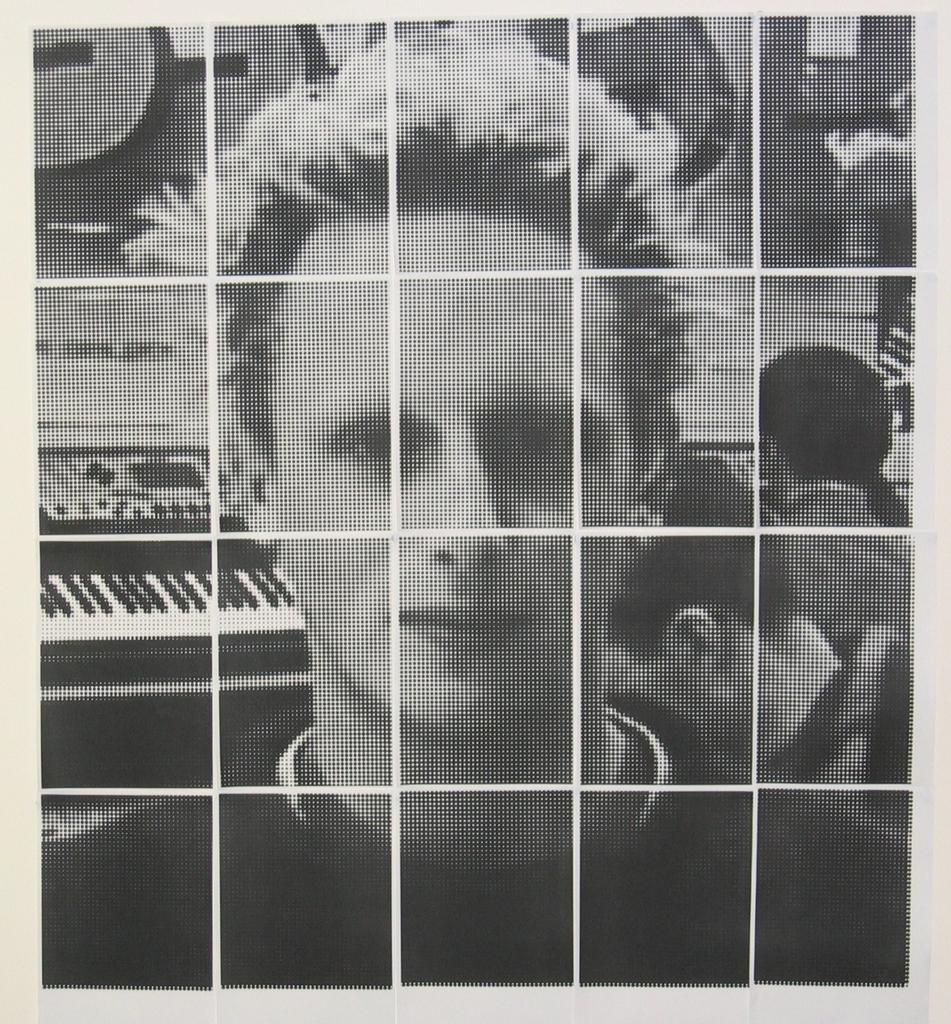How has the image been altered? The image is edited and black and white. Can you describe the main subject of the image? There is a person in the image. What can be seen in the background of the image? There is a hoarding in the background with a picture of a piano on it. How many people are present in the image? There are two people standing in the image. Are there any men holding umbrellas in the image? There is no mention of men or umbrellas in the provided facts, so we cannot determine their presence in the image. Can you see any deer in the image? There is no mention of deer in the provided facts, so we cannot determine their presence in the image. 